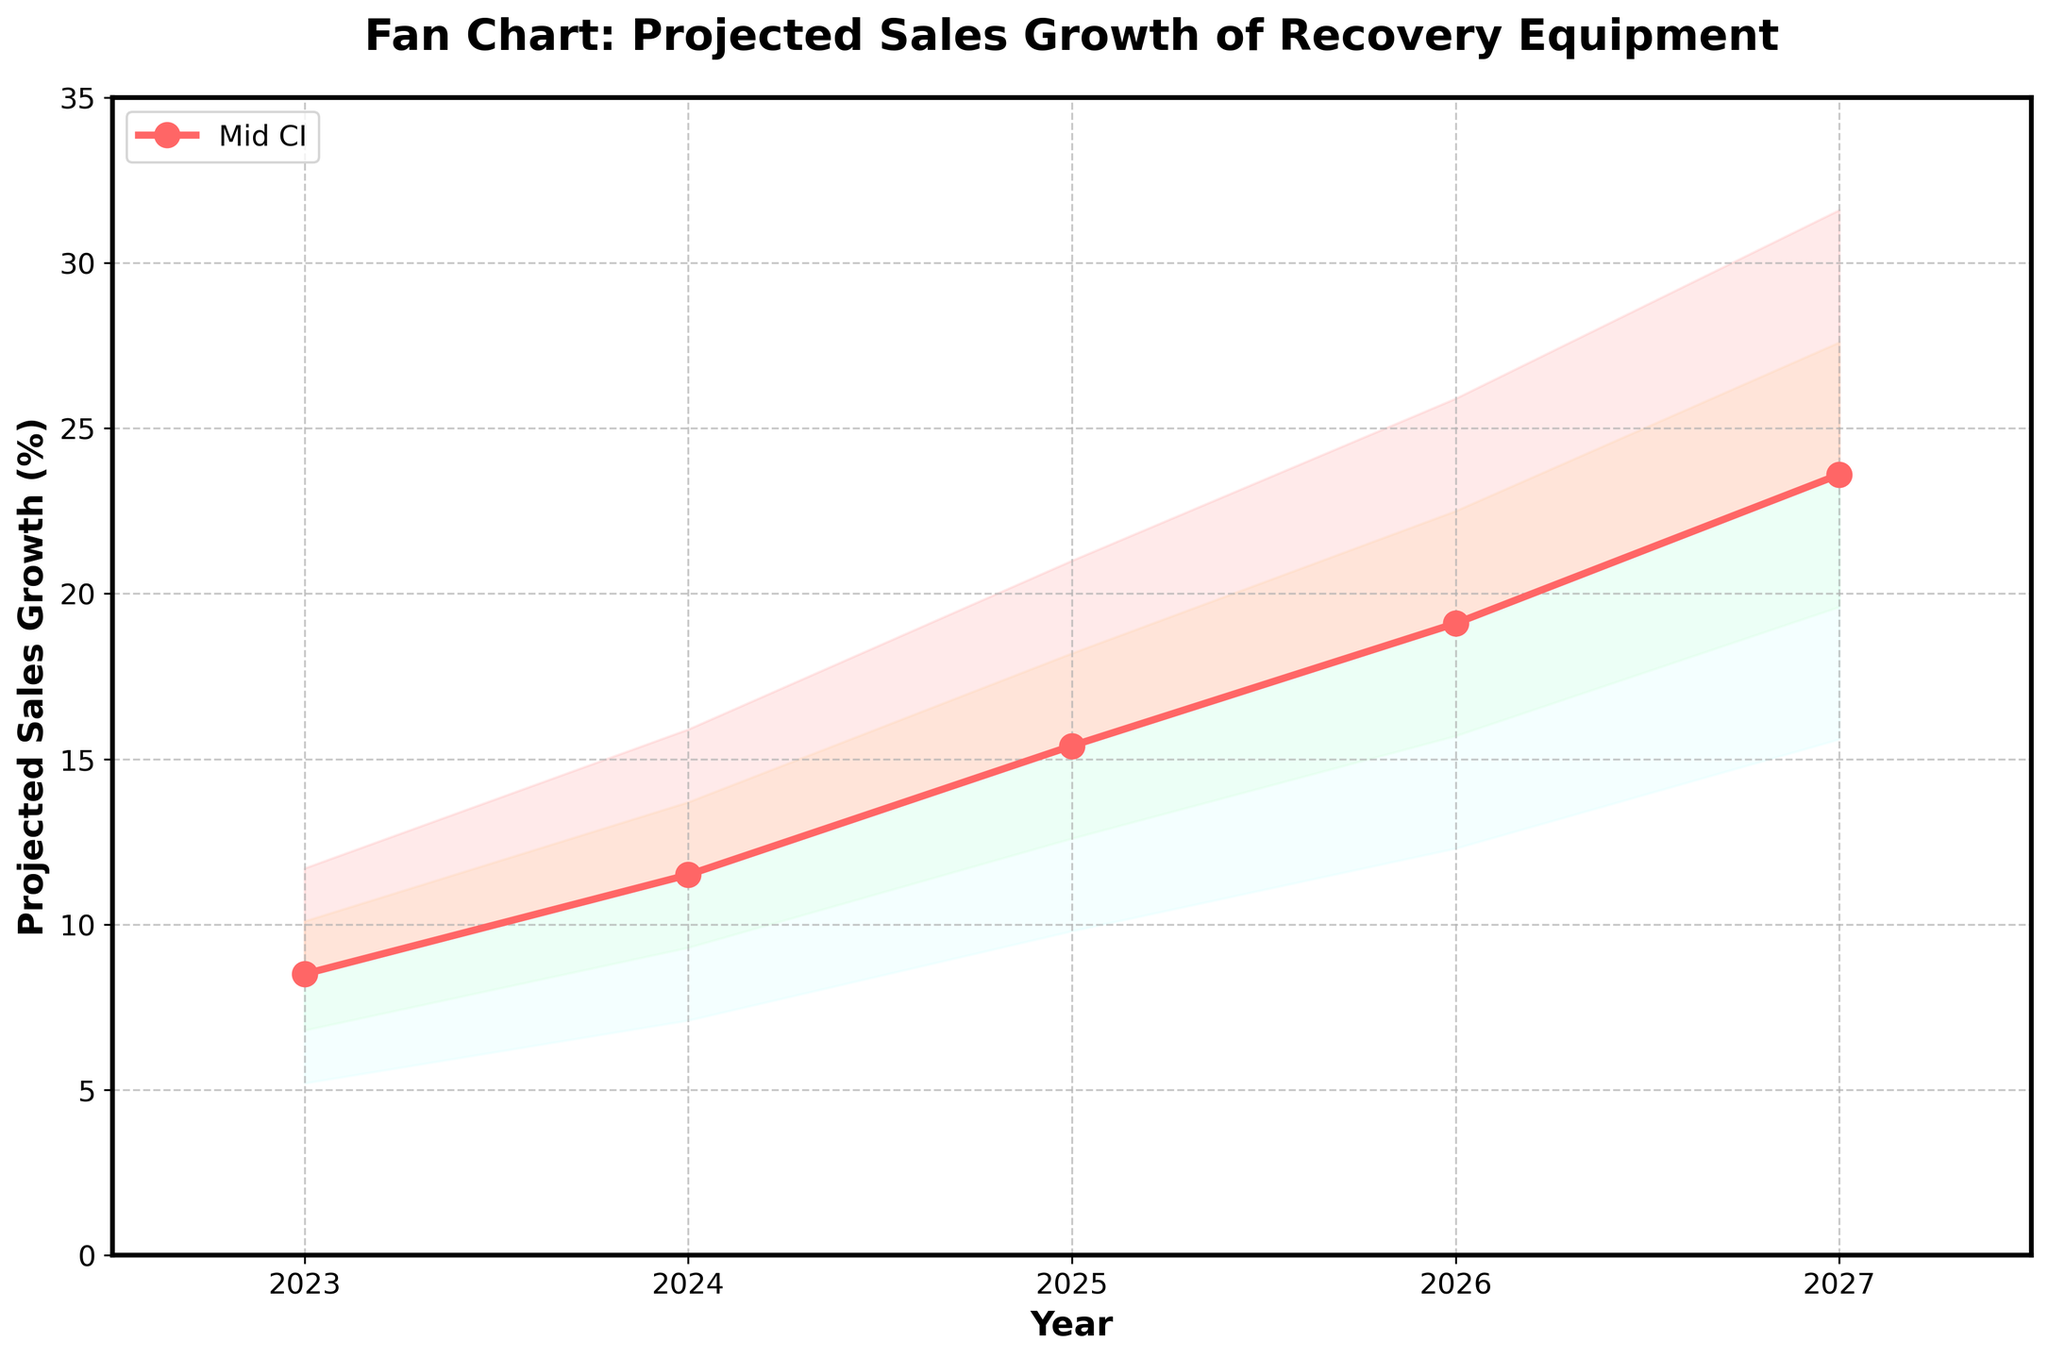What is the title of the chart? The title is provided at the top of the chart in bold and large font. It reads "Fan Chart: Projected Sales Growth of Recovery Equipment".
Answer: "Fan Chart: Projected Sales Growth of Recovery Equipment" What value does the Mid CI line reach in 2025? Looking at the data point for the year 2025 on the Mid CI line, it is indicated to be 15.4%.
Answer: 15.4% How does the projected sales growth change from 2023 to 2027 according to the Mid CI? By finding the Mid CI for 2023 and 2027 and subtracting the 2023 value from the 2027 value: 23.6 - 8.5 = 15.1, it can be seen that the sales growth increases by 15.1 percentage points.
Answer: Increases by 15.1 percentage points Which year has the smallest range between the Low CI and High CI values? By comparing the ranges (High CI - Low CI) for each year: 2023 (11.7 - 5.2 = 6.5), 2024 (15.9 - 7.1 = 8.8), 2025 (21.0 - 9.8 = 11.2), 2026 (25.9 - 12.3 = 13.6), 2027 (31.6 - 15.6 = 16.0), it is clear that 2023 has the smallest range of 6.5 percentage points.
Answer: 2023 What is the projected percentage increase from 2024 to 2026 according to the Low-Mid CI? Subtract the Low-Mid CI value in 2024 from the Low-Mid CI value in 2026: 15.7 - 9.3 = 6.4, indicating a 6.4 percentage point increase.
Answer: 6.4 percentage points Which color band represents the highest confidence interval? Observing the color bands, the one representing the highest confidence interval (High CI) is the topmost band, which is light blue in color.
Answer: Light blue By how much does the Mid-High CI value in 2027 exceed the Mid-High CI value in 2023? Subtract the 2023 Mid-High CI value from the 2027 Mid-High CI value: 27.6 - 10.1 = 17.5. This means it exceeds by 17.5 percentage points.
Answer: 17.5 percentage points What is the projected sales growth in 2026 within the Mid-High CI? The Mid-High CI value for 2026 is provided directly in the chart and is 22.5%.
Answer: 22.5% How many years are displayed on the x-axis? By counting the number of data points represented along the x-axis, it is clear that there are 5 years displayed: from 2023 to 2027.
Answer: 5 years 